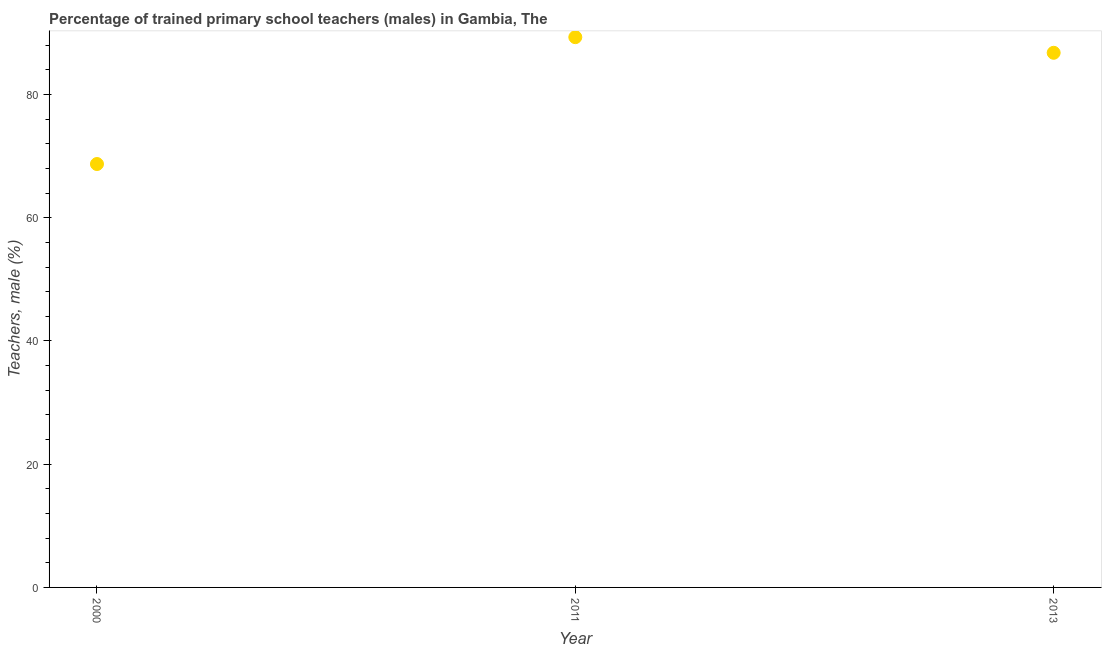What is the percentage of trained male teachers in 2013?
Your answer should be compact. 86.77. Across all years, what is the maximum percentage of trained male teachers?
Offer a terse response. 89.3. Across all years, what is the minimum percentage of trained male teachers?
Your response must be concise. 68.72. In which year was the percentage of trained male teachers maximum?
Provide a succinct answer. 2011. What is the sum of the percentage of trained male teachers?
Make the answer very short. 244.79. What is the difference between the percentage of trained male teachers in 2000 and 2013?
Your answer should be very brief. -18.05. What is the average percentage of trained male teachers per year?
Your answer should be compact. 81.6. What is the median percentage of trained male teachers?
Your response must be concise. 86.77. In how many years, is the percentage of trained male teachers greater than 28 %?
Make the answer very short. 3. What is the ratio of the percentage of trained male teachers in 2000 to that in 2011?
Offer a very short reply. 0.77. Is the percentage of trained male teachers in 2000 less than that in 2011?
Offer a very short reply. Yes. Is the difference between the percentage of trained male teachers in 2000 and 2011 greater than the difference between any two years?
Offer a very short reply. Yes. What is the difference between the highest and the second highest percentage of trained male teachers?
Provide a short and direct response. 2.54. What is the difference between the highest and the lowest percentage of trained male teachers?
Give a very brief answer. 20.59. Does the percentage of trained male teachers monotonically increase over the years?
Your answer should be compact. No. Does the graph contain any zero values?
Provide a short and direct response. No. Does the graph contain grids?
Provide a succinct answer. No. What is the title of the graph?
Provide a succinct answer. Percentage of trained primary school teachers (males) in Gambia, The. What is the label or title of the X-axis?
Your answer should be compact. Year. What is the label or title of the Y-axis?
Your response must be concise. Teachers, male (%). What is the Teachers, male (%) in 2000?
Provide a short and direct response. 68.72. What is the Teachers, male (%) in 2011?
Offer a very short reply. 89.3. What is the Teachers, male (%) in 2013?
Your response must be concise. 86.77. What is the difference between the Teachers, male (%) in 2000 and 2011?
Make the answer very short. -20.59. What is the difference between the Teachers, male (%) in 2000 and 2013?
Offer a very short reply. -18.05. What is the difference between the Teachers, male (%) in 2011 and 2013?
Give a very brief answer. 2.54. What is the ratio of the Teachers, male (%) in 2000 to that in 2011?
Offer a terse response. 0.77. What is the ratio of the Teachers, male (%) in 2000 to that in 2013?
Keep it short and to the point. 0.79. 